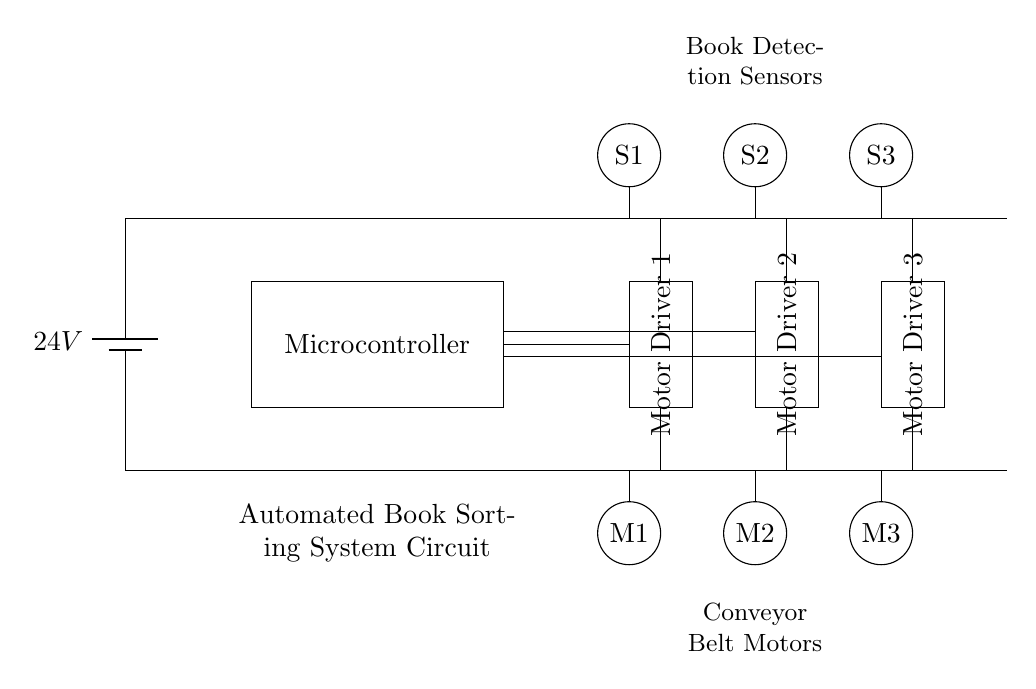What is the power supply voltage? The circuit is powered by a battery, labeled as providing 24 volts at the top left corner of the diagram. This indicates the voltage supplied to the entire circuit.
Answer: 24V What components are used to detect books? The circuit includes three sensors labeled S1, S2, and S3 located at the top of the diagram. These components are specifically placed to detect books in the automated sorting system.
Answer: S1, S2, S3 How many motor drivers are in the circuit? The diagram shows three distinct motor drivers labeled as Motor Driver 1, Motor Driver 2, and Motor Driver 3. Each driver is placed adjacent to a corresponding motor, indicating their function in controlling the motors.
Answer: 3 What is the purpose of the microcontroller? The microcontroller, represented in the rectangle, acts as the control unit for the entire automated system. It processes inputs from the sensors and sends commands to the motor drivers based on those inputs to operate the motors.
Answer: Control unit Which components are responsible for moving the books? The motors M1, M2, and M3 situated at the lower section of the diagram, each connected to respective motor drivers, are responsible for the movement of books along the conveyor belt.
Answer: M1, M2, M3 What is the connection pattern between the microcontroller and the motor drivers? There are wires connecting the microcontroller directly to the motor drivers, indicating a communication link where the microcontroller sends signals to the motor drivers to activate the motors based on sensor input.
Answer: Direct connection 